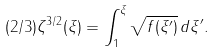<formula> <loc_0><loc_0><loc_500><loc_500>( 2 / 3 ) \zeta ^ { 3 / 2 } ( \xi ) = \int _ { 1 } ^ { \xi } \sqrt { f ( \xi ^ { \prime } ) } \, d \xi ^ { \prime } .</formula> 